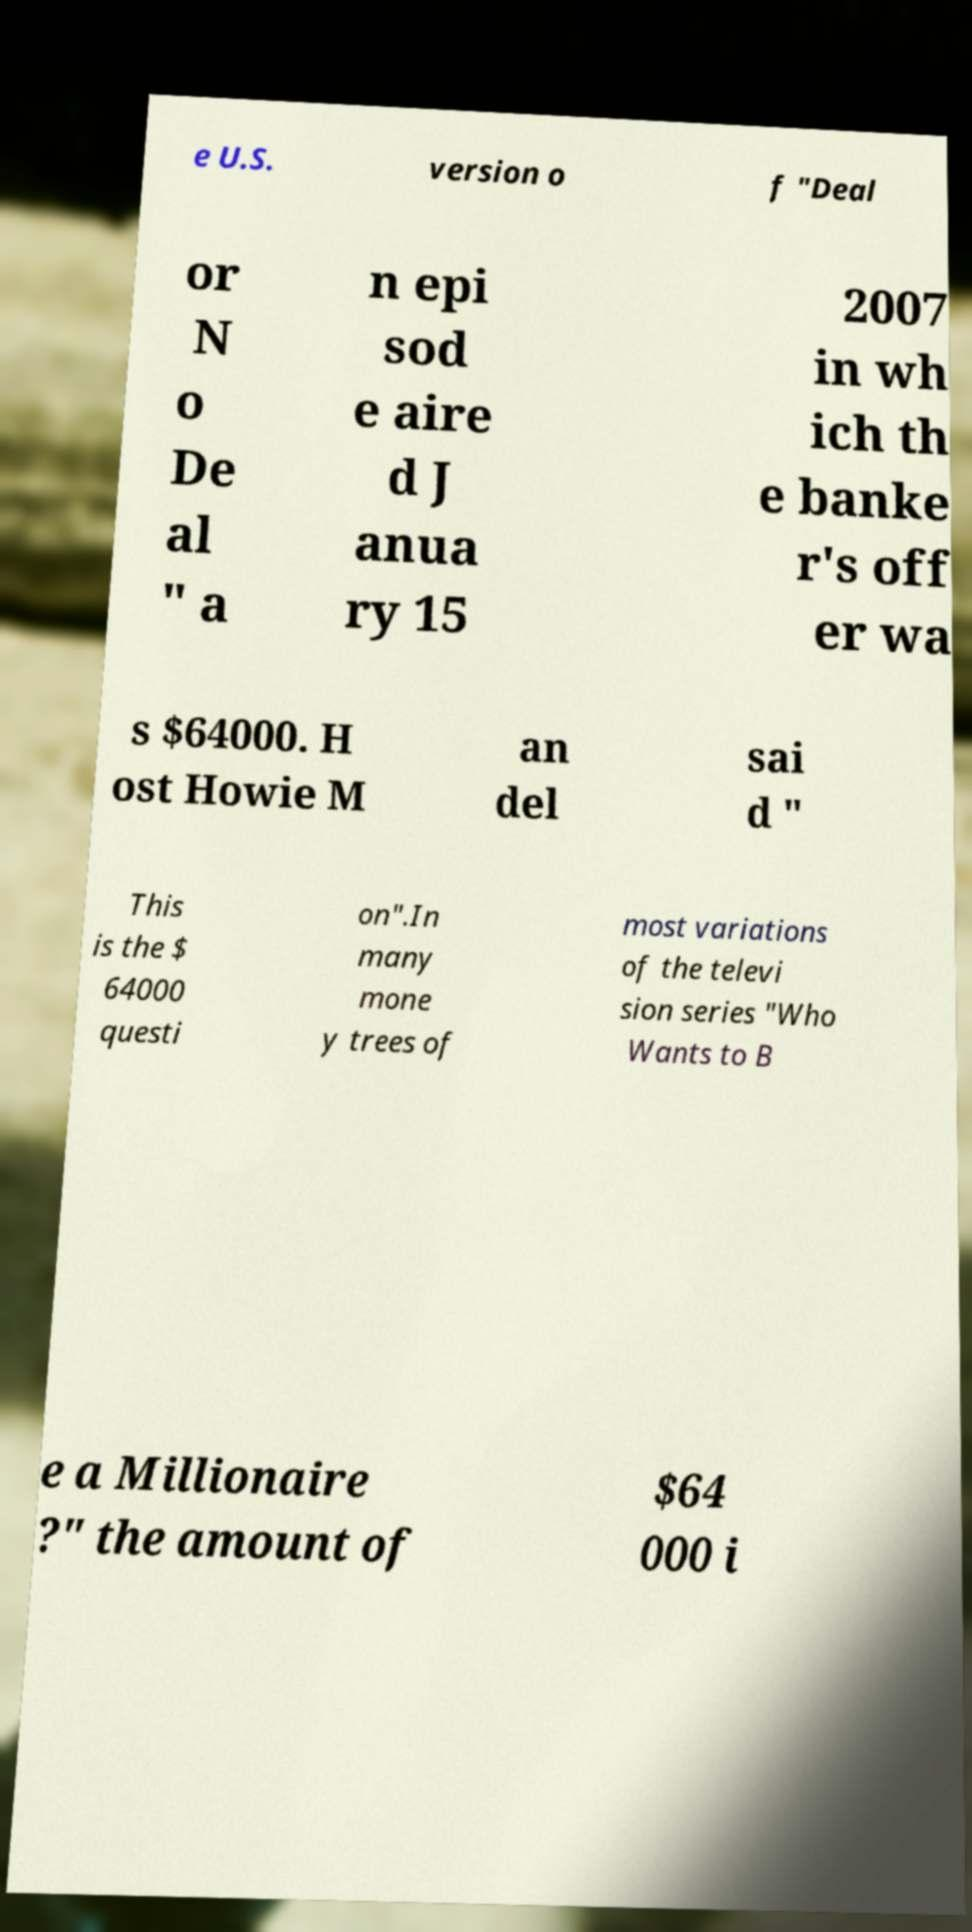Please read and relay the text visible in this image. What does it say? e U.S. version o f "Deal or N o De al " a n epi sod e aire d J anua ry 15 2007 in wh ich th e banke r's off er wa s $64000. H ost Howie M an del sai d " This is the $ 64000 questi on".In many mone y trees of most variations of the televi sion series "Who Wants to B e a Millionaire ?" the amount of $64 000 i 